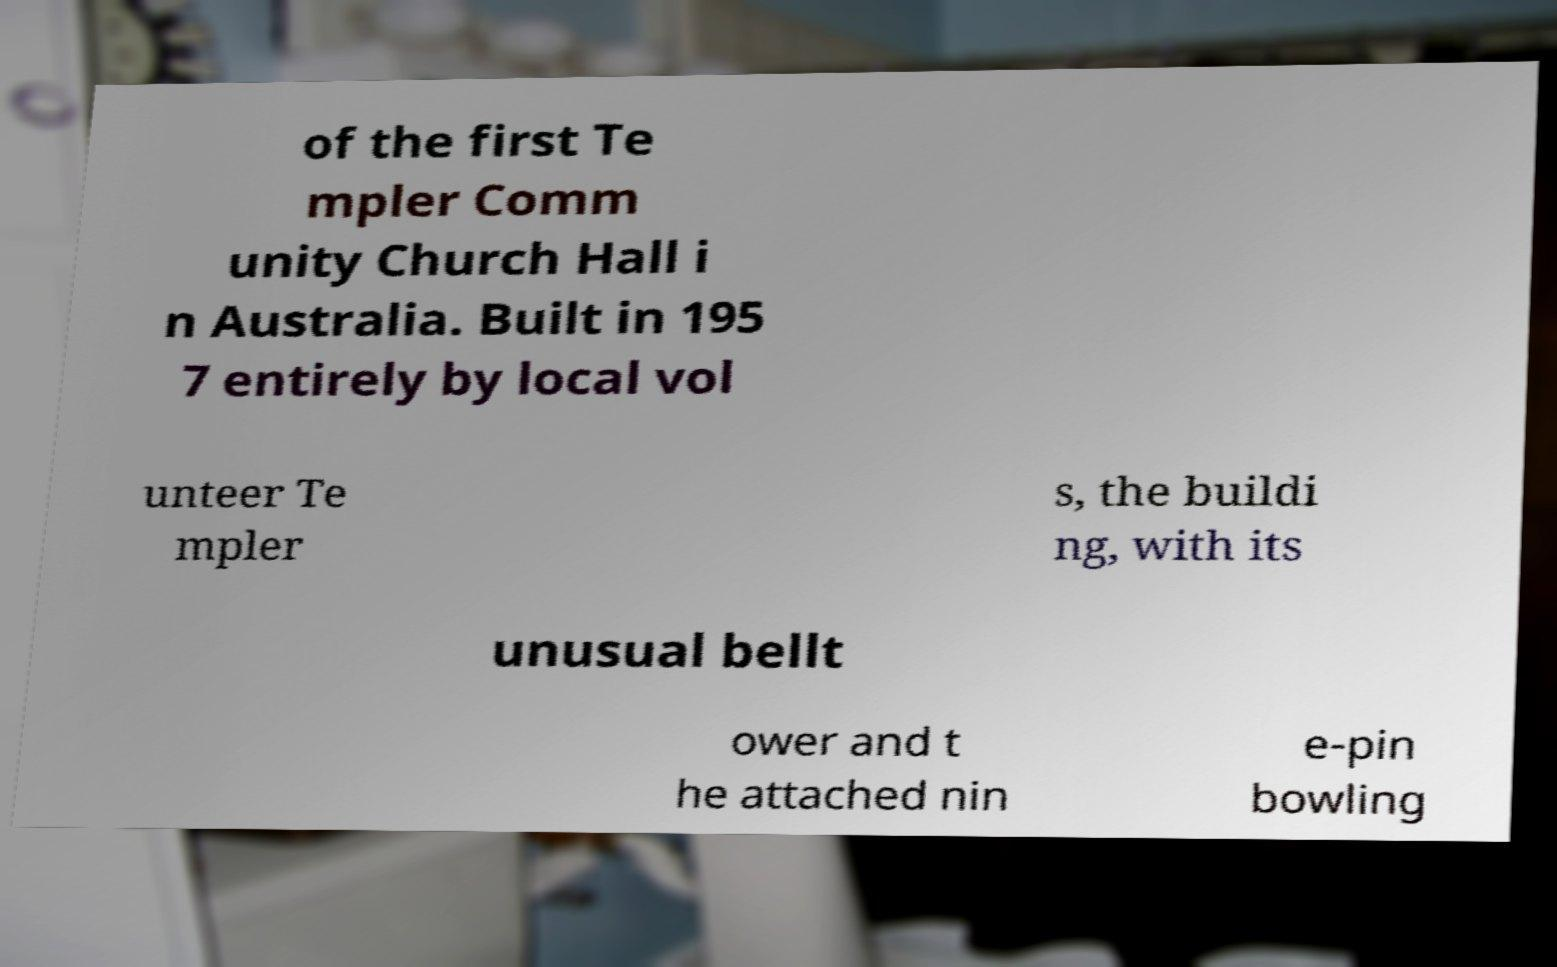Please read and relay the text visible in this image. What does it say? of the first Te mpler Comm unity Church Hall i n Australia. Built in 195 7 entirely by local vol unteer Te mpler s, the buildi ng, with its unusual bellt ower and t he attached nin e-pin bowling 